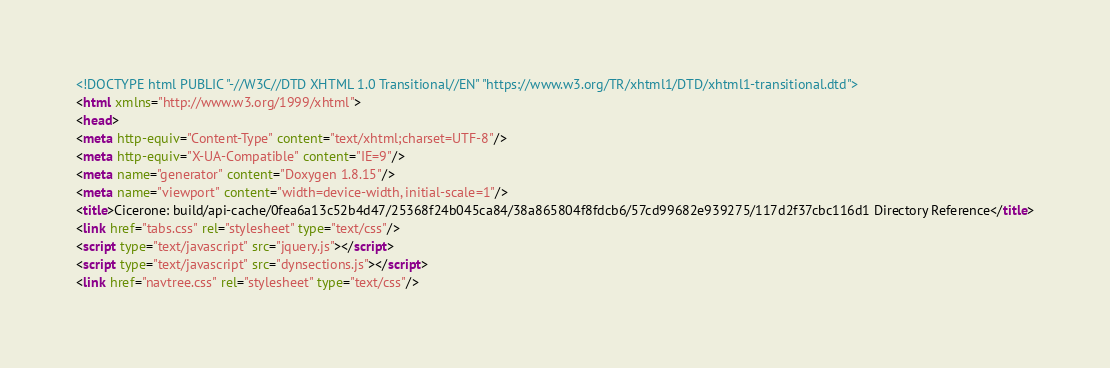<code> <loc_0><loc_0><loc_500><loc_500><_HTML_><!DOCTYPE html PUBLIC "-//W3C//DTD XHTML 1.0 Transitional//EN" "https://www.w3.org/TR/xhtml1/DTD/xhtml1-transitional.dtd">
<html xmlns="http://www.w3.org/1999/xhtml">
<head>
<meta http-equiv="Content-Type" content="text/xhtml;charset=UTF-8"/>
<meta http-equiv="X-UA-Compatible" content="IE=9"/>
<meta name="generator" content="Doxygen 1.8.15"/>
<meta name="viewport" content="width=device-width, initial-scale=1"/>
<title>Cicerone: build/api-cache/0fea6a13c52b4d47/25368f24b045ca84/38a865804f8fdcb6/57cd99682e939275/117d2f37cbc116d1 Directory Reference</title>
<link href="tabs.css" rel="stylesheet" type="text/css"/>
<script type="text/javascript" src="jquery.js"></script>
<script type="text/javascript" src="dynsections.js"></script>
<link href="navtree.css" rel="stylesheet" type="text/css"/></code> 